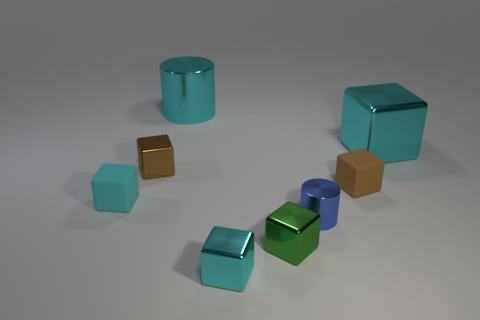Subtract all brown spheres. How many cyan blocks are left? 3 Subtract all green blocks. How many blocks are left? 5 Subtract all small cyan matte blocks. How many blocks are left? 5 Subtract all yellow blocks. Subtract all blue cylinders. How many blocks are left? 6 Add 2 tiny green objects. How many objects exist? 10 Subtract all cylinders. How many objects are left? 6 Subtract 0 blue balls. How many objects are left? 8 Subtract all tiny brown rubber things. Subtract all tiny cyan rubber things. How many objects are left? 6 Add 6 large cyan cylinders. How many large cyan cylinders are left? 7 Add 3 tiny cyan metallic objects. How many tiny cyan metallic objects exist? 4 